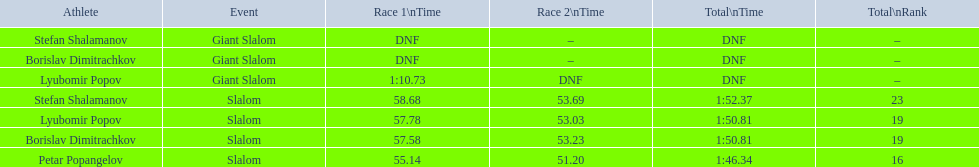What event represents the giant slalom? Giant Slalom, Giant Slalom, Giant Slalom. Can lyubomir popov be identified? Lyubomir Popov. When does the first race begin? 1:10.73. 